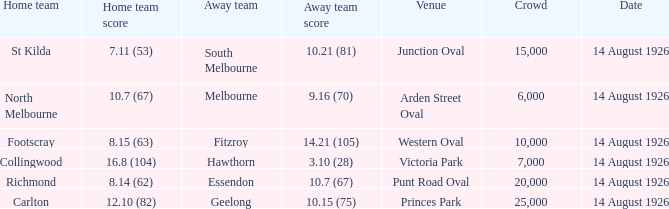What was the smallest crowd that watched an away team score 3.10 (28)? 7000.0. 